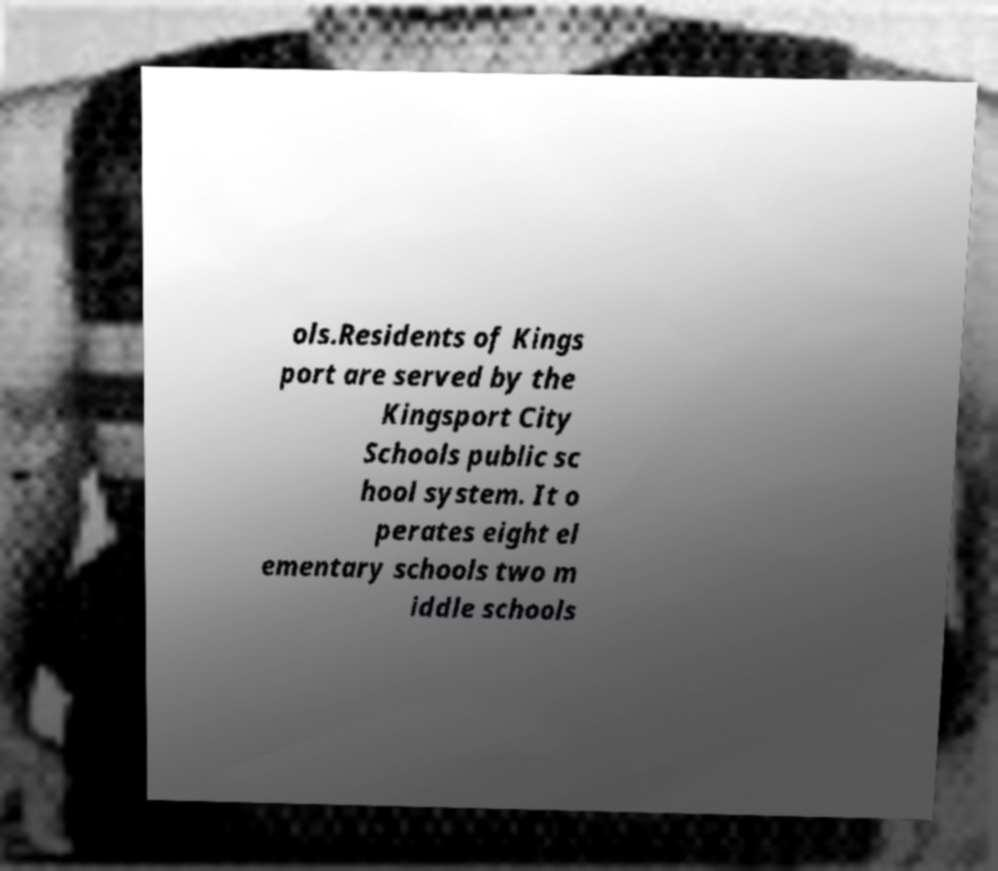For documentation purposes, I need the text within this image transcribed. Could you provide that? ols.Residents of Kings port are served by the Kingsport City Schools public sc hool system. It o perates eight el ementary schools two m iddle schools 